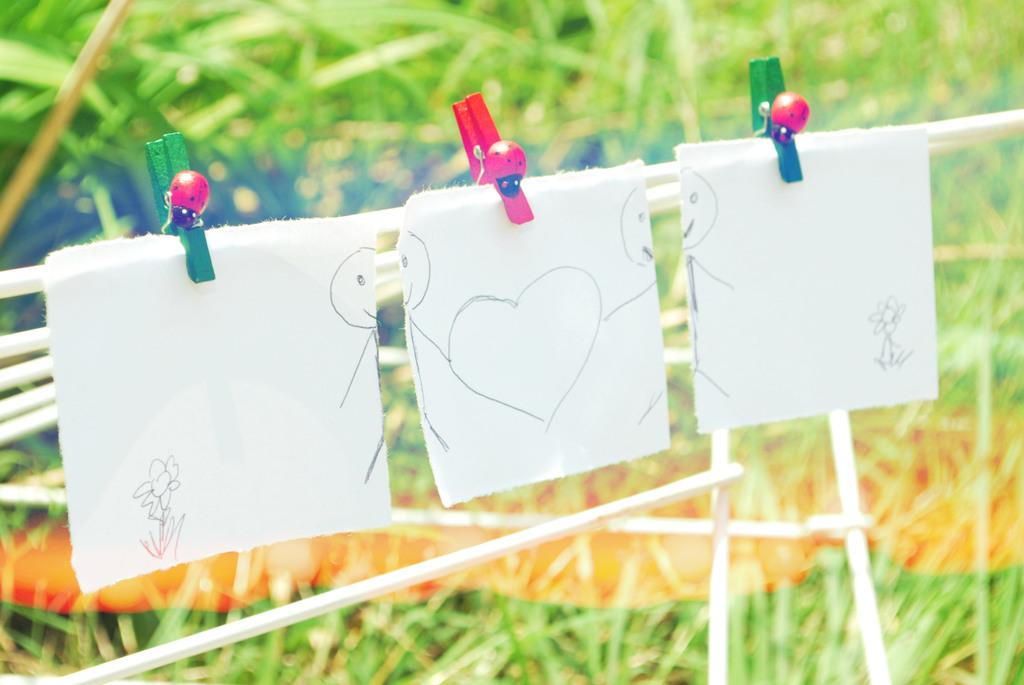What is the main object in the image? There is a white color stand in the image. What is attached to the stand? Three papers with drawings are hanged on the stand using clips. Are there any insects on the stand? Yes, there are bugs on the lips of the stand. Can you describe the background of the image? The background of the image is green and blurred. What type of cloud can be seen in the image? There is no cloud present in the image. How does the temper of the person who drew the pictures affect the quality of the drawings? The facts provided do not mention any person or their temper, so we cannot determine how it might affect the quality of the drawings. 